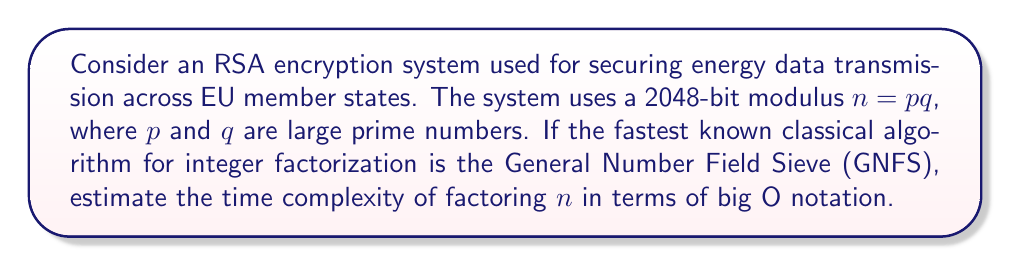Help me with this question. To determine the computational complexity of factoring large prime numbers for RSA encryption, we need to consider the following steps:

1. The General Number Field Sieve (GNFS) is currently the most efficient classical algorithm for factoring large integers.

2. The time complexity of GNFS is given by:

   $$O(exp((c + o(1))(ln n)^{1/3}(ln ln n)^{2/3}))$$

   where $c$ is a constant approximately equal to $(64/9)^{1/3} \approx 1.923$.

3. For a 2048-bit RSA modulus, $n$ is approximately $2^{2048}$.

4. Substituting this into the complexity formula:

   $$O(exp((1.923 + o(1))(ln 2^{2048})^{1/3}(ln ln 2^{2048})^{2/3}))$$

5. Simplifying:
   
   $$O(exp((1.923 + o(1))(2048 \ln 2)^{1/3}(ln(2048 \ln 2))^{2/3}))$$

6. This can be further approximated as:

   $$O(exp((\sqrt[3]{64/9} + o(1)) \cdot \sqrt[3]{2048 \ln 2} \cdot (ln(2048 \ln 2))^{2/3}))$$

7. The $o(1)$ term becomes negligible for large $n$, so we can omit it in the final expression.

Therefore, the time complexity of factoring a 2048-bit RSA modulus using GNFS is approximately:

$$O(exp(\sqrt[3]{64/9} \cdot \sqrt[3]{2048 \ln 2} \cdot (ln(2048 \ln 2))^{2/3}))$$
Answer: $O(exp(\sqrt[3]{64/9} \cdot \sqrt[3]{2048 \ln 2} \cdot (ln(2048 \ln 2))^{2/3}))$ 